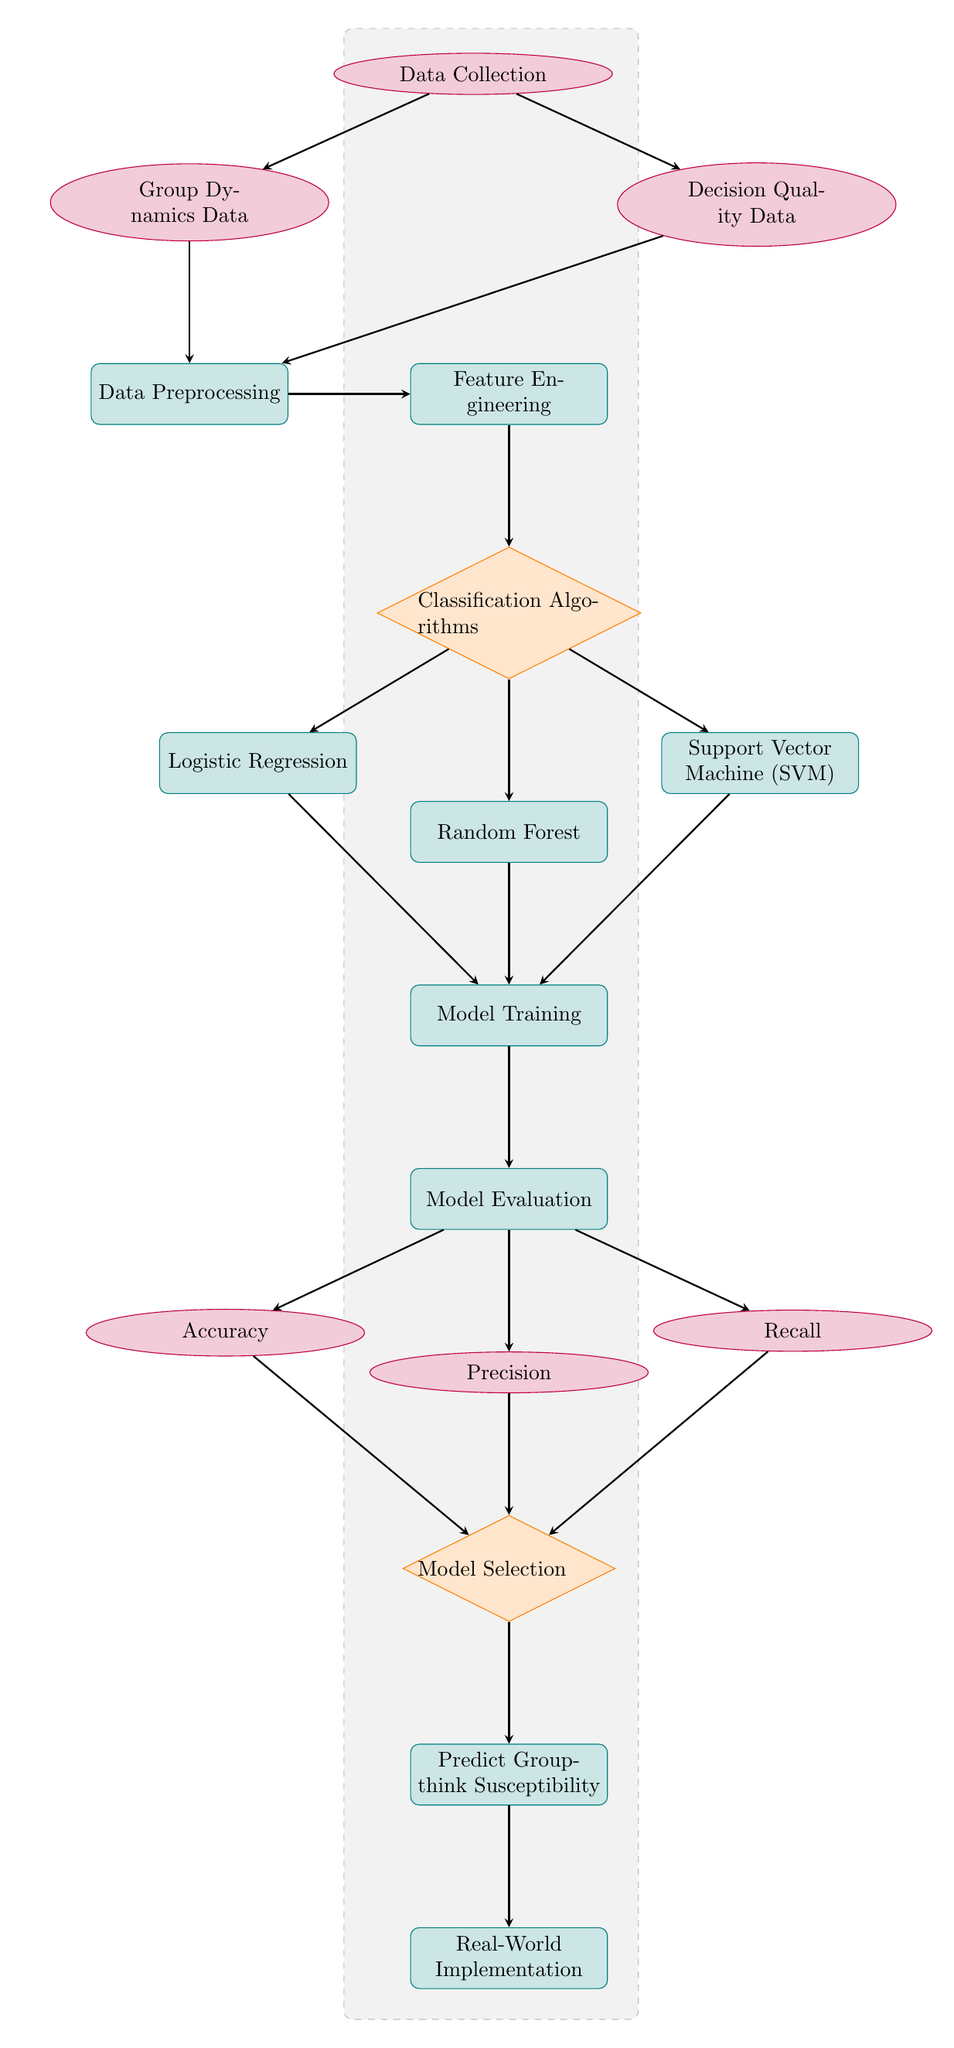What are the two types of data collected? The diagram identifies two types of data collected: Group Dynamics Data and Decision Quality Data, both of which are shown as data nodes directly connected to the Data Collection node.
Answer: Group Dynamics Data, Decision Quality Data How many classification algorithms are shown? The diagram depicts three classification algorithms, represented as process nodes beneath the Classification Algorithms decision node.
Answer: Three What is the first step after data preprocessing? After data preprocessing, the next step is Feature Engineering, which is directly connected below the Data Preprocessing process node in the diagram.
Answer: Feature Engineering Which nodes are evaluated to select the model? The model selection considers three evaluation metrics: Accuracy, Precision, and Recall, which are data nodes directly connected to the Model Selection decision node.
Answer: Accuracy, Precision, Recall What is the final process before real-world implementation? The final process before real-world implementation is Predict Groupthink Susceptibility, which is the node directly above the Real-World Implementation process node.
Answer: Predict Groupthink Susceptibility Explain the flow from data collection to model evaluation. The flow starts with Data Collection, which leads to Group Dynamics Data and Decision Quality Data. Both data nodes flow into Data Preprocessing, which then connects to Feature Engineering. This leads to the Classification Algorithms node, where paths diverge to Logistic Regression, Random Forest, and Support Vector Machine (SVM). All three algorithms connect to Model Training, which then flows into Model Evaluation.
Answer: Data Collection → Group Dynamics Data, Decision Quality Data → Data Preprocessing → Feature Engineering → Classification Algorithms → Logistic Regression, Random Forest, SVM → Model Training → Model Evaluation What type of node is used to represent classification algorithms? The classification algorithms are represented as process nodes, indicated by their rectangular shape and rounded corners in the diagram.
Answer: Process nodes How many features are considered for model evaluation? Three features—Accuracy, Precision, and Recall—are considered for model evaluation, as depicted in the diagram with three individual data nodes connected to the Model Evaluation process node.
Answer: Three Which process directly follows the model training step? The process that directly follows the Model Training step is Model Evaluation, represented as a process node in the diagram linked by an arrow.
Answer: Model Evaluation 